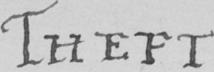Transcribe the text shown in this historical manuscript line. THEFT . 